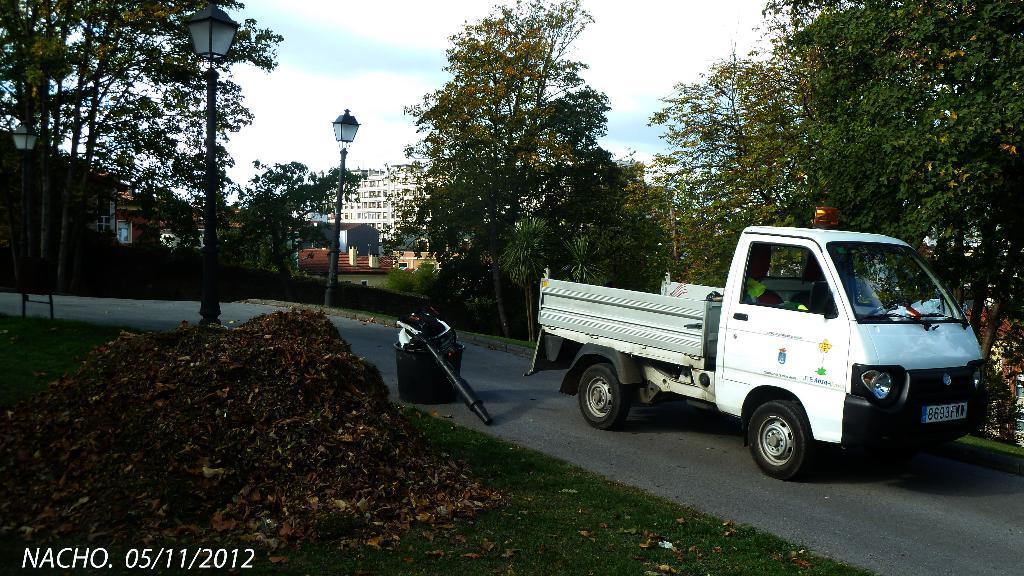Could you give a brief overview of what you see in this image? In this picture there is a road in the center. On the road there is a truck which is in white in color. There are three lights in the picture. Towards the left corner there are dry leaves and a device is placed on the road. In the background there are buildings and group of trees. 